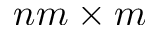Convert formula to latex. <formula><loc_0><loc_0><loc_500><loc_500>n m \times m</formula> 